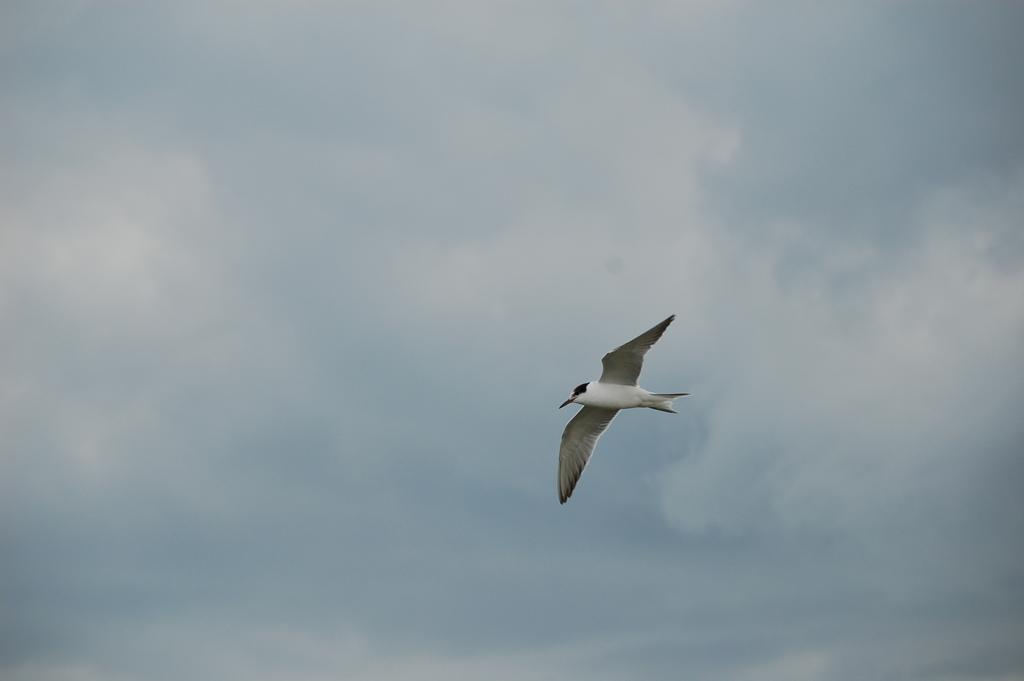In one or two sentences, can you explain what this image depicts? This image consists of a bird. It is in white color. There is the sky in this image. 